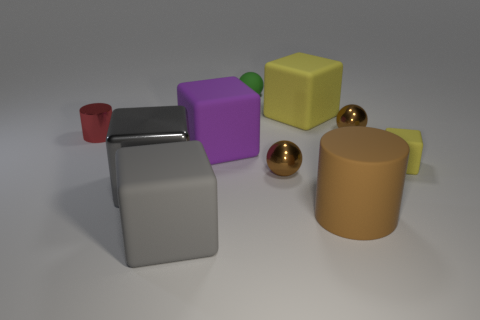What time of day does the lighting in the image suggest? The lighting in the image does not strongly suggest a specific time of day as it seems to be a studio setup with neutral, soft lighting typically used in product photography or 3D renderings to avoid harsh shadows and provide even illumination. 